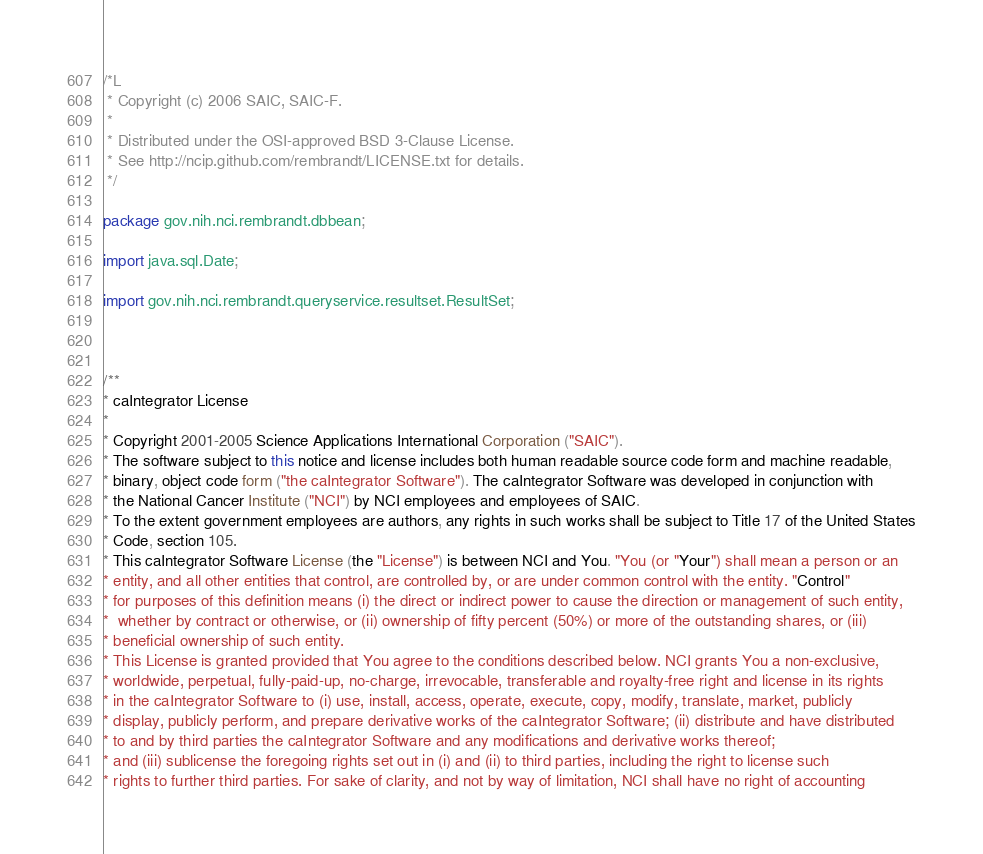<code> <loc_0><loc_0><loc_500><loc_500><_Java_>/*L
 * Copyright (c) 2006 SAIC, SAIC-F.
 *
 * Distributed under the OSI-approved BSD 3-Clause License.
 * See http://ncip.github.com/rembrandt/LICENSE.txt for details.
 */

package gov.nih.nci.rembrandt.dbbean;

import java.sql.Date;

import gov.nih.nci.rembrandt.queryservice.resultset.ResultSet;



/**
* caIntegrator License
* 
* Copyright 2001-2005 Science Applications International Corporation ("SAIC"). 
* The software subject to this notice and license includes both human readable source code form and machine readable, 
* binary, object code form ("the caIntegrator Software"). The caIntegrator Software was developed in conjunction with 
* the National Cancer Institute ("NCI") by NCI employees and employees of SAIC. 
* To the extent government employees are authors, any rights in such works shall be subject to Title 17 of the United States
* Code, section 105. 
* This caIntegrator Software License (the "License") is between NCI and You. "You (or "Your") shall mean a person or an 
* entity, and all other entities that control, are controlled by, or are under common control with the entity. "Control" 
* for purposes of this definition means (i) the direct or indirect power to cause the direction or management of such entity,
*  whether by contract or otherwise, or (ii) ownership of fifty percent (50%) or more of the outstanding shares, or (iii) 
* beneficial ownership of such entity. 
* This License is granted provided that You agree to the conditions described below. NCI grants You a non-exclusive, 
* worldwide, perpetual, fully-paid-up, no-charge, irrevocable, transferable and royalty-free right and license in its rights 
* in the caIntegrator Software to (i) use, install, access, operate, execute, copy, modify, translate, market, publicly 
* display, publicly perform, and prepare derivative works of the caIntegrator Software; (ii) distribute and have distributed 
* to and by third parties the caIntegrator Software and any modifications and derivative works thereof; 
* and (iii) sublicense the foregoing rights set out in (i) and (ii) to third parties, including the right to license such 
* rights to further third parties. For sake of clarity, and not by way of limitation, NCI shall have no right of accounting</code> 